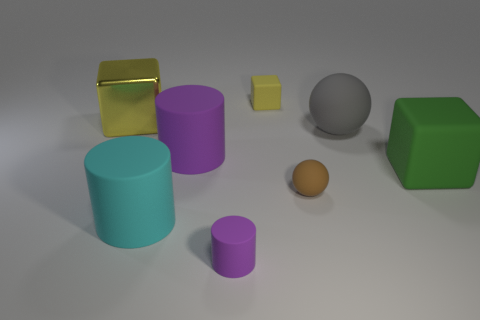What shapes are present in this collection of objects? The objects include a variety of geometric shapes: cylinders, cubes, a sphere, and a rectangular prism. Which object seems to be the smallest, and what color is it? The smallest object appears to be the tiny light-brown sphere. 